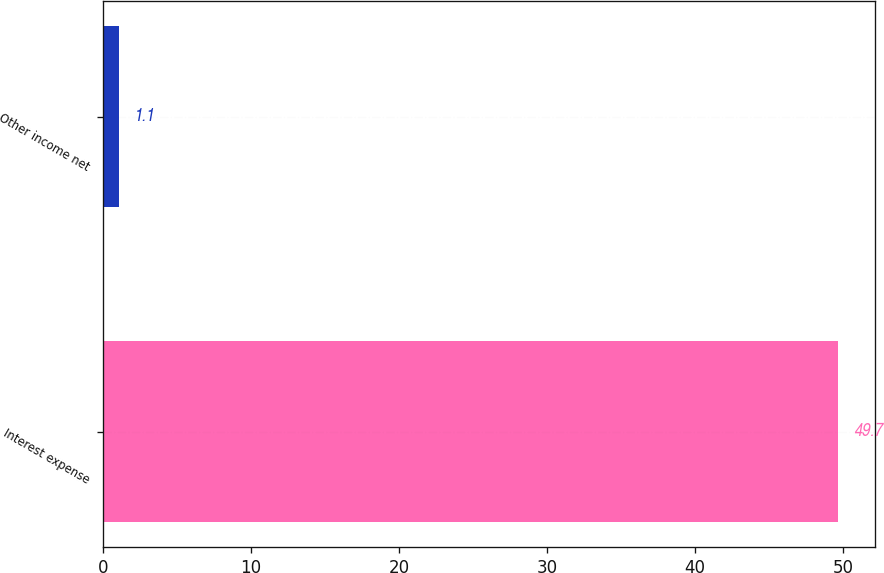<chart> <loc_0><loc_0><loc_500><loc_500><bar_chart><fcel>Interest expense<fcel>Other income net<nl><fcel>49.7<fcel>1.1<nl></chart> 